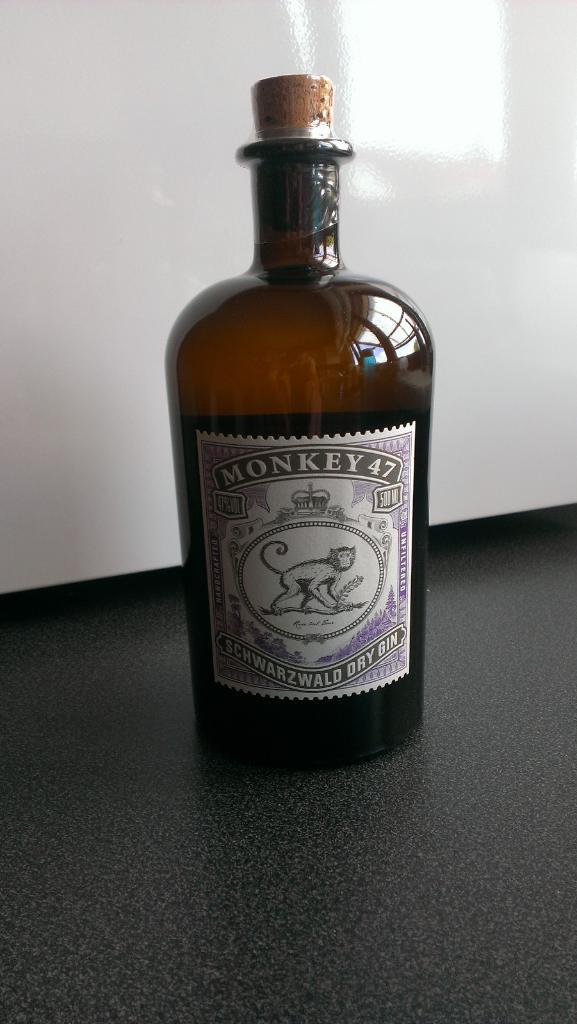What object can be seen in the image? There is a bottle in the image. What is on the bottle? The bottle has a sticker on it. What information is on the sticker? The sticker has the name "monkey 47 schwarzwald dry gin." What image is on the sticker? There is a monkey image on the sticker. How many mice are visible on the lace in the image? There are no mice or lace present in the image. What type of tramp is shown sitting next to the bottle in the image? There is no tramp present in the image; it only features a bottle with a sticker on it. 